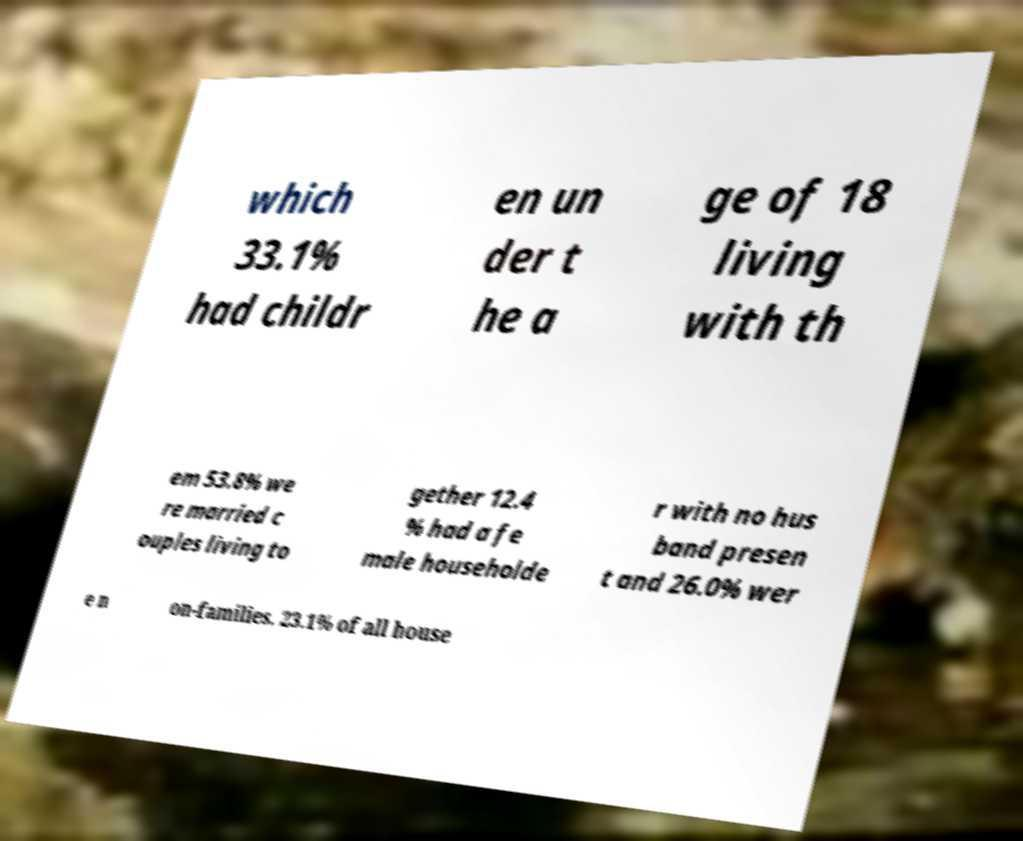Can you accurately transcribe the text from the provided image for me? which 33.1% had childr en un der t he a ge of 18 living with th em 53.8% we re married c ouples living to gether 12.4 % had a fe male householde r with no hus band presen t and 26.0% wer e n on-families. 23.1% of all house 